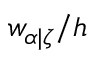Convert formula to latex. <formula><loc_0><loc_0><loc_500><loc_500>w _ { \alpha | \zeta } / h</formula> 